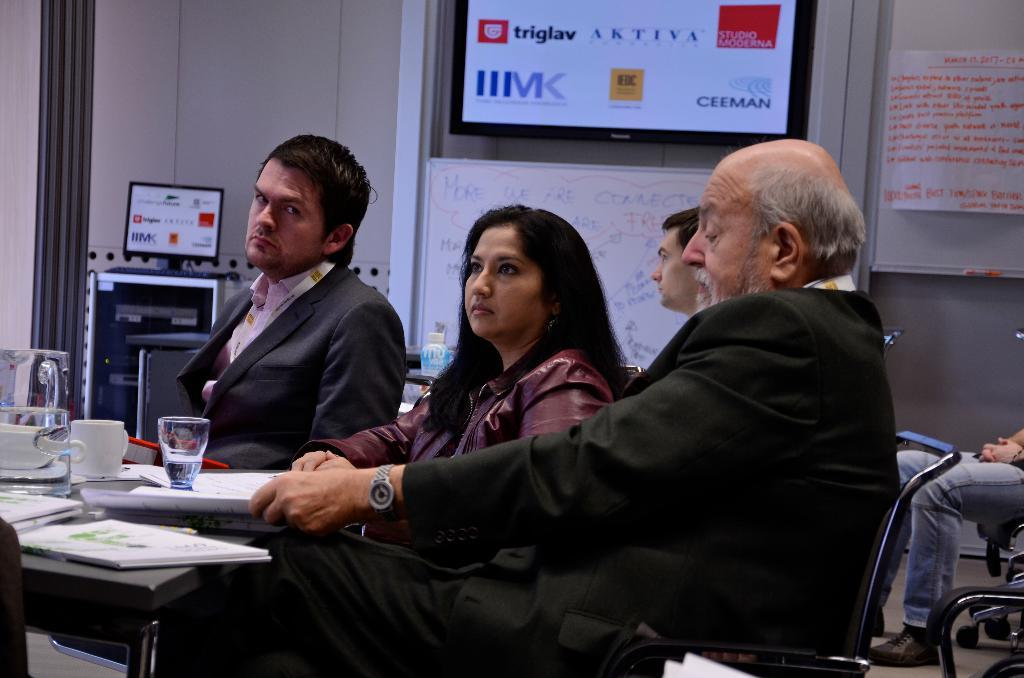How many people are sitting in the image? There are four people sitting on chairs in the image. What objects are on the table? There is a cup and a book on the table. What can be seen at the back side of the image? There is a screen and a system at the back side. What type of railway can be seen in the image? There is no railway present in the image. How does the sponge help the people in the image? There is no sponge present in the image, so it cannot help the people. 